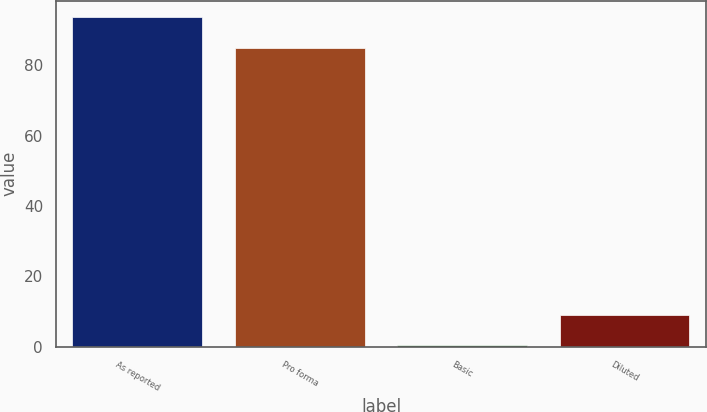Convert chart. <chart><loc_0><loc_0><loc_500><loc_500><bar_chart><fcel>As reported<fcel>Pro forma<fcel>Basic<fcel>Diluted<nl><fcel>93.76<fcel>85<fcel>0.4<fcel>9.16<nl></chart> 